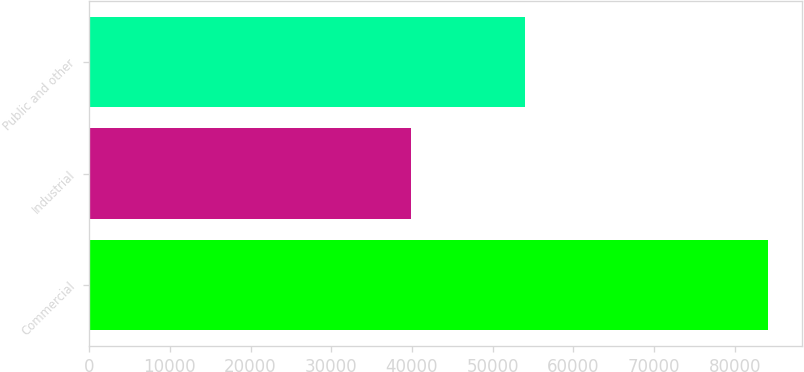Convert chart. <chart><loc_0><loc_0><loc_500><loc_500><bar_chart><fcel>Commercial<fcel>Industrial<fcel>Public and other<nl><fcel>84086<fcel>39860<fcel>54059<nl></chart> 